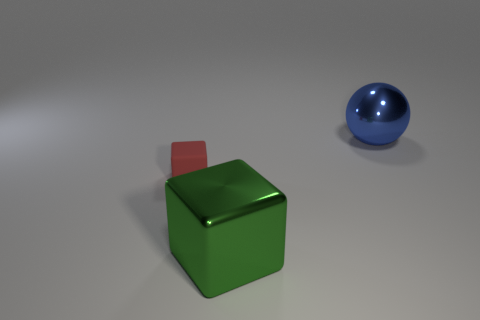Subtract all green blocks. How many blocks are left? 1 Subtract all spheres. How many objects are left? 2 Subtract 1 spheres. How many spheres are left? 0 Subtract all gray cubes. Subtract all yellow balls. How many cubes are left? 2 Subtract all brown cylinders. How many yellow spheres are left? 0 Subtract all rubber cubes. Subtract all small rubber things. How many objects are left? 1 Add 2 rubber cubes. How many rubber cubes are left? 3 Add 1 green objects. How many green objects exist? 2 Add 1 blue spheres. How many objects exist? 4 Subtract 0 purple cylinders. How many objects are left? 3 